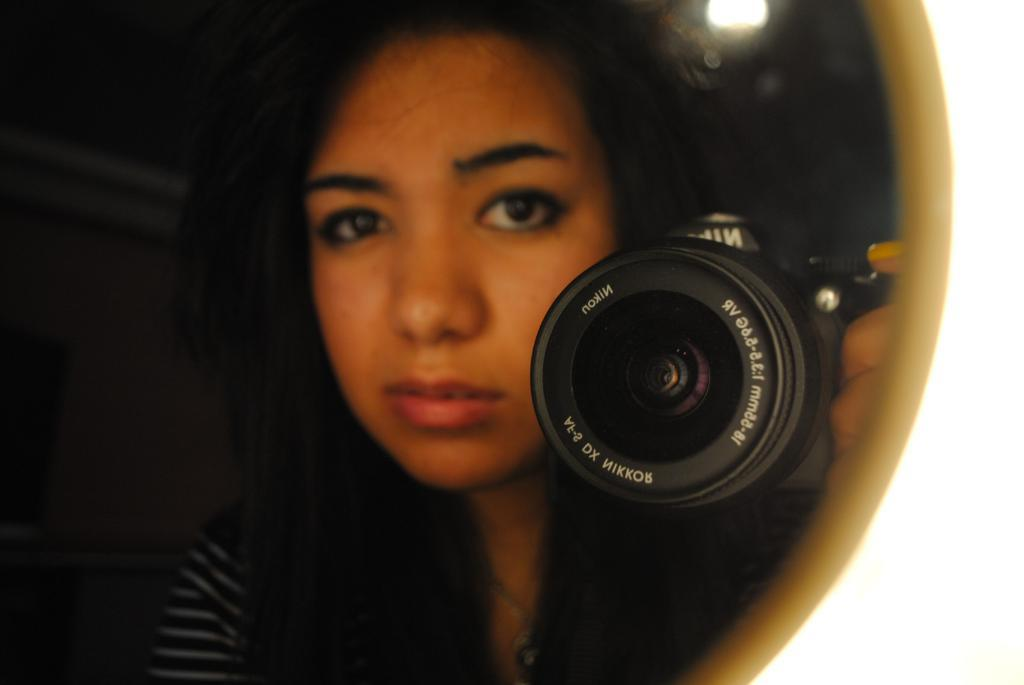What is the main subject of the image? There is a person in the image. What is the person holding in the image? The person is holding a camera. Can you describe any other objects or features in the image? There is a light in the image. How would you describe the overall appearance of the image? The background of the image is dark. What type of feather can be seen on the person's head in the image? There is no feather present on the person's head in the image. Is the person's father also visible in the image? The provided facts do not mention the presence of the person's father in the image. 